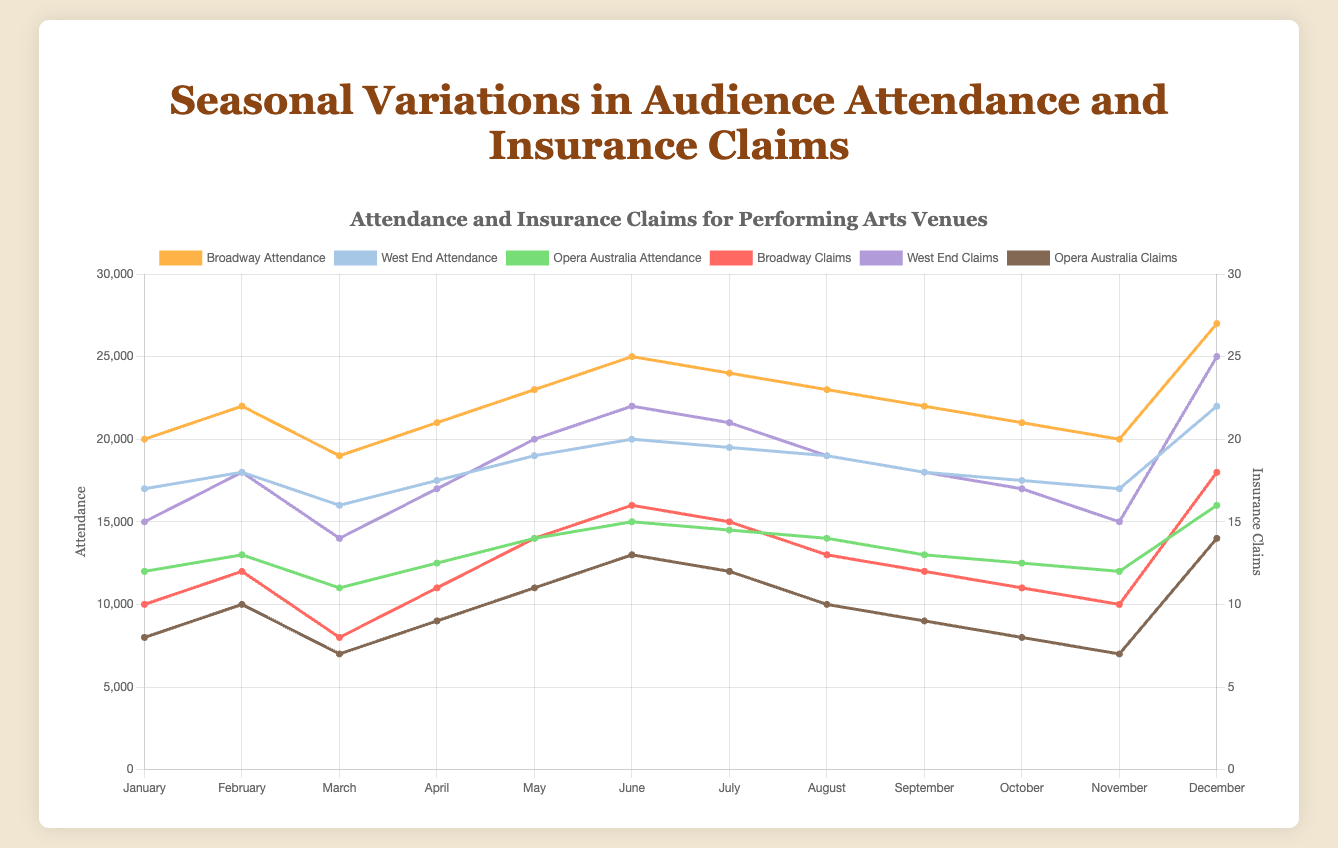What is the range of Broadway's attendance across the year? To find the range of Broadway's attendance, we take the highest value (27000 in December) and subtract the lowest value (19000 in March). So, 27000 - 19000 = 8000.
Answer: 8000 Which month had the highest number of insurance claims for West End? By examining the insurance claims for West End across each month, we find that the highest number of claims (25) occurred in December.
Answer: December Do Broadway's attendance and insurance claims peak in the same month? By comparing the peaks, Broadway's attendance peaks in December (27000) and its insurance claims also peak in December (18). Both attendance and insurance claims peak in December.
Answer: Yes In which month does Opera Australia's attendance have the lowest number of claims? From the data, Opera Australia's lowest insurance claims occur in March (7 claims), matching with the lowest attendance month of March (11000).
Answer: March Compare the total insurance claims of Broadway and West End in June. Which one is higher? Summing June's insurance claims for Broadway (16) and West End (22), we see that West End has higher claims: 22 claims compared to Broadway's 16.
Answer: West End What is the combined attendance of Broadway and West End in November? Adding up November's attendance for Broadway (20000) and West End (17000), we have a total of 37000.
Answer: 37000 Is there a positive correlation between attendance and insurance claims for Broadway? Observing Broadway’s data, as attendance increases, insurance claims also tend to increase (e.g., low attendance in March with low claims, high attendance in December with high claims). This suggests a positive correlation.
Answer: Yes Which opera company had the least variability in attendance throughout the year? By evaluating the range of attendance for the three companies, Opera Australia ranges from 11000 to 16000, showing the least variability (a range of 5000).
Answer: Opera Australia How many months had Broadway more than 20,000 attendees? Noting the months with more than 20,000 attendees for Broadway, we count: February, April, May, June, July, August, September, October, December (9 months total).
Answer: 9 Which month had the smallest difference in insurance claims between Broadway and West End? The differences in insurance claims each month are computed (for example, January: 15 - 10 = 5, February: 18 - 12 = 6). March has the smallest difference of 6 (14 - 8).
Answer: March 